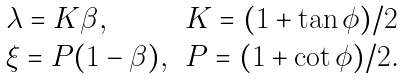<formula> <loc_0><loc_0><loc_500><loc_500>\begin{array} { l l } \lambda = K \beta , & K = ( 1 + \tan \phi ) / 2 \\ \xi = P ( 1 - \beta ) , & P = ( 1 + \cot \phi ) / 2 . \\ \end{array}</formula> 